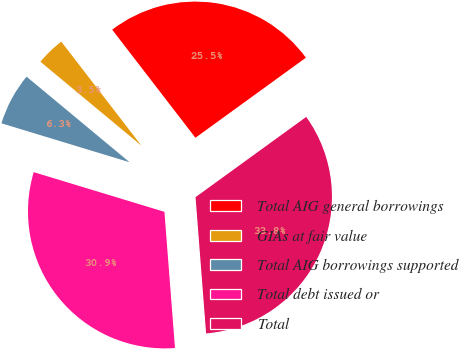Convert chart. <chart><loc_0><loc_0><loc_500><loc_500><pie_chart><fcel>Total AIG general borrowings<fcel>GIAs at fair value<fcel>Total AIG borrowings supported<fcel>Total debt issued or<fcel>Total<nl><fcel>25.46%<fcel>3.52%<fcel>6.34%<fcel>30.92%<fcel>33.75%<nl></chart> 